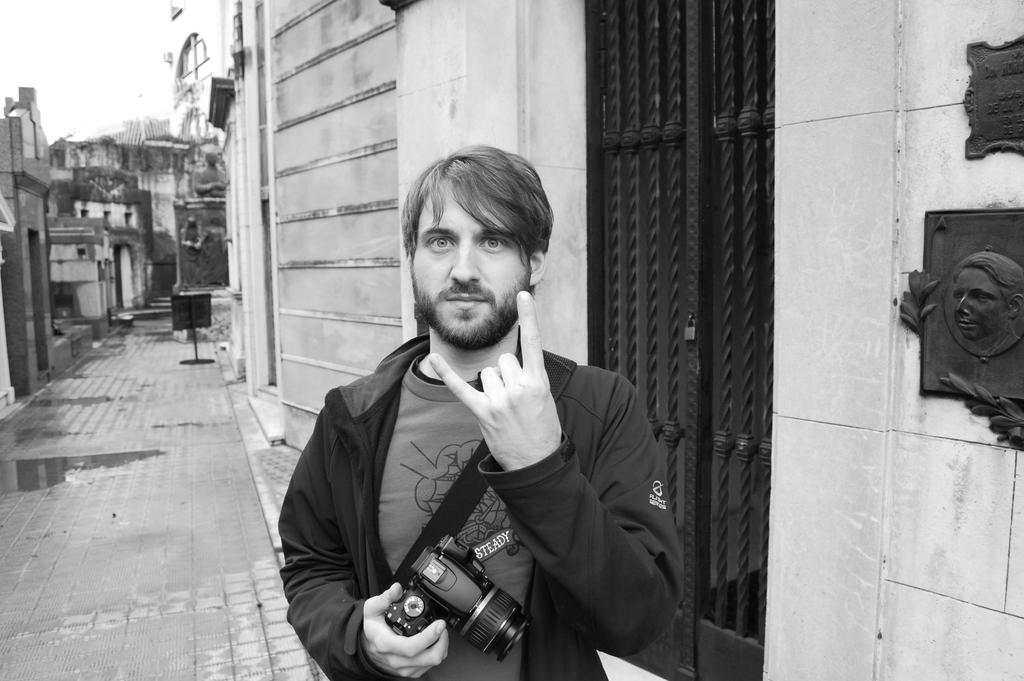What is the color scheme of the image? The image is black and white. What type of structures can be seen in the image? There are buildings in the image. What is the person in the image doing? The person is standing and giving a still. What object is the person holding in the image? The person is holding a camera. What type of artwork is present on a wall in the image? There is a sculpture on a wall in the image. What type of door can be seen in the image? There is a door with a lock in the image. What type of cup is being used to water the seed in the image? There is no cup or seed present in the image. 